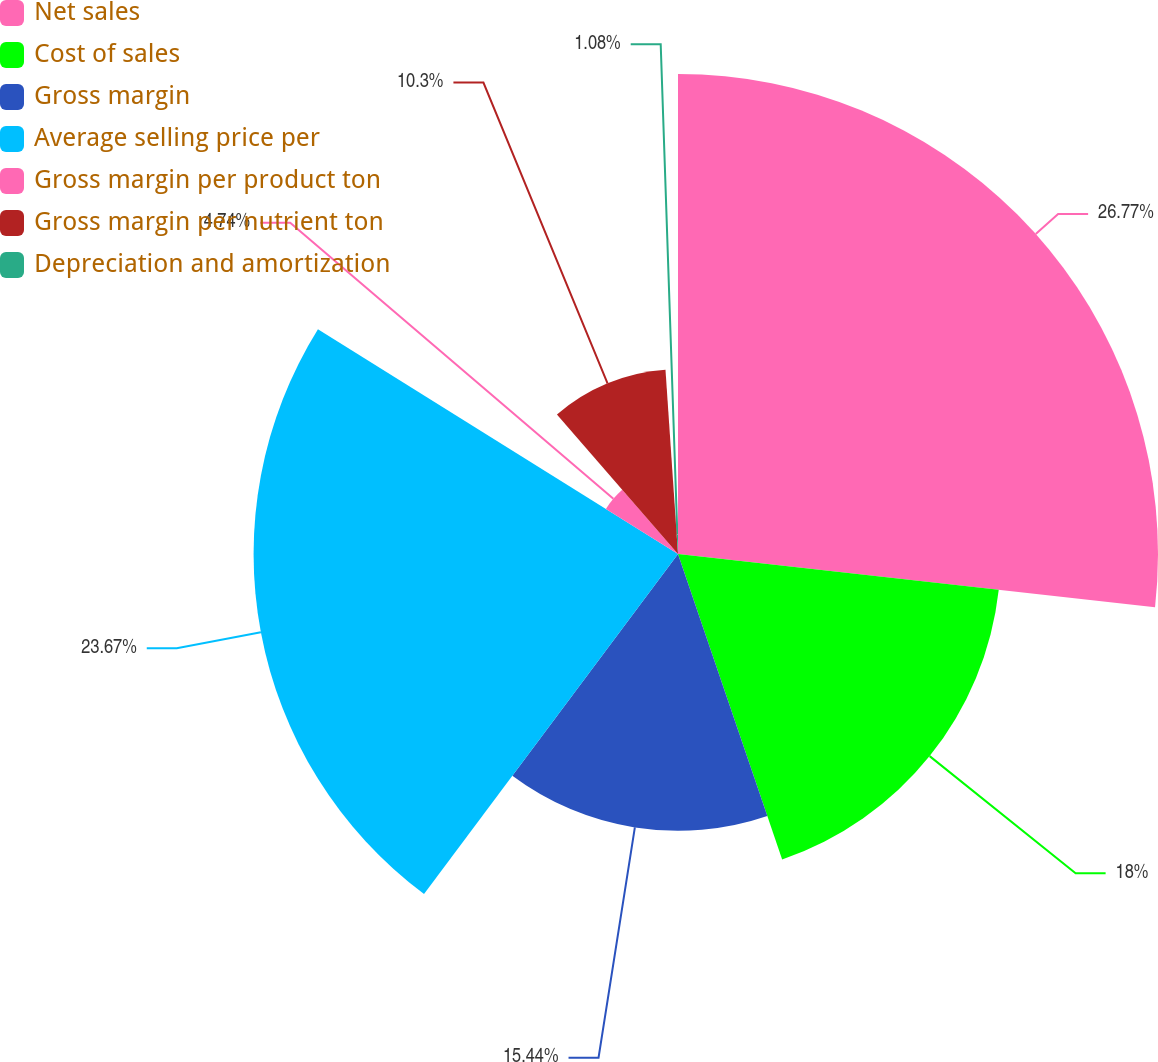<chart> <loc_0><loc_0><loc_500><loc_500><pie_chart><fcel>Net sales<fcel>Cost of sales<fcel>Gross margin<fcel>Average selling price per<fcel>Gross margin per product ton<fcel>Gross margin per nutrient ton<fcel>Depreciation and amortization<nl><fcel>26.77%<fcel>18.0%<fcel>15.44%<fcel>23.67%<fcel>4.74%<fcel>10.3%<fcel>1.08%<nl></chart> 